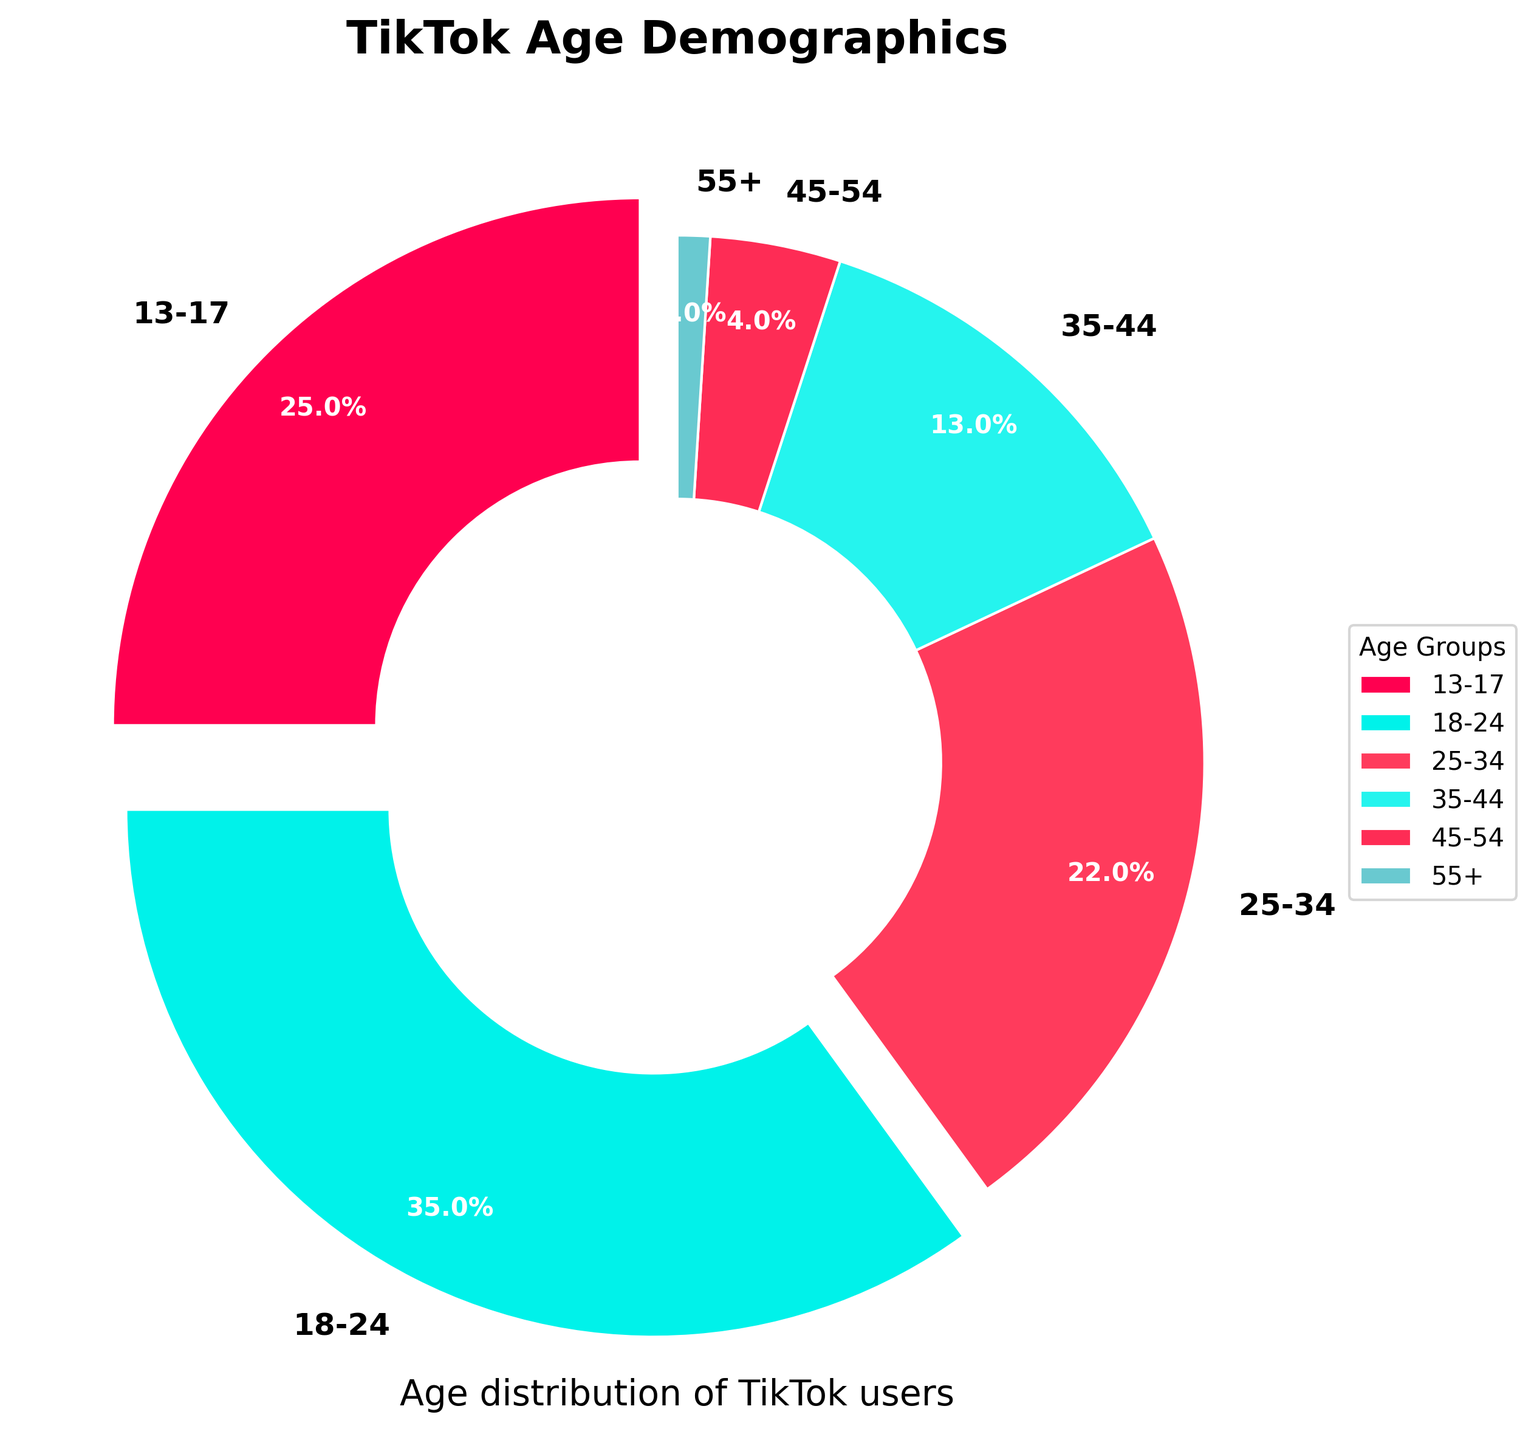What is the age group with the highest percentage of TikTok users? By looking at the pie chart, the segment representing the 18-24 age group is the largest. This is indicated by the largest area corresponding to this group on the chart.
Answer: 18-24 Which age group's segment is highlighted with an explode effect in the pie chart? The 13-17 and 18-24 age groups have wedges that are slightly separated from the pie chart, which is an explode effect used to emphasize them.
Answer: 13-17 and 18-24 How does the age distribution of TikTok users compare to Facebook users for the 25-34 age group? From the data, TikTok users aged 25-34 make up 22%, whereas Facebook users in the same age group make up 25%. This is visually supported by the pie chart where the 25-34 segment is larger in Facebook than in TikTok.
Answer: TikTok: 22%, Facebook: 25% What percentage of TikTok's users are under 25 years old? The under 25 group includes the 13-17 and 18-24 age ranges. Adding their percentages: 25% (13-17) + 35% (18-24) = 60%.
Answer: 60% How does the 13-17 age group in TikTok's demographics compare to Twitter's for the same group? The pie chart shows that 25% of TikTok users are in the 13-17 age group, compared to only 3% for Twitter users in the same age group.
Answer: TikTok: 25%, Twitter: 3% In a pie chart, what visual feature helps you identify the largest segment quickly? The largest segment is usually the one with the biggest area or arc length, which stands out visually among other segments.
Answer: Largest area Compare TikTok's demographic for users aged 35-44 with Instagram's. TikTok's 35-44 age group accounts for 13%, while Instagram's 35-44 age group makes up 18%. This is clear from comparing the corresponding segments in the pie chart for both platforms.
Answer: TikTok: 13%, Instagram: 18% What is the combined percentage of TikTok users aged 45 and above? The combined percentage for the 45-54 and 55+ age groups can be found by adding 4% (45-54) + 1% (55+). Thus, the combined percentage is 5%.
Answer: 5% Which age group has the smallest representation among TikTok users and what might be one visual clue to indicate this on the pie chart? The 55+ age group has the smallest representation at 1%, which can be identified by the smallest segment or wedge in the pie chart.
Answer: 55+, smallest segment Among the age demographics, which age group is common between TikTok's and Facebook's primary user base? Both TikTok and Facebook have a significant number of users in the 25-34 age group, making it a common focal point in their user demographics.
Answer: 25-34 